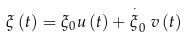Convert formula to latex. <formula><loc_0><loc_0><loc_500><loc_500>\xi \left ( t \right ) = \xi _ { 0 } u \left ( t \right ) + \stackrel { \cdot } { \xi } _ { 0 } v \left ( t \right )</formula> 